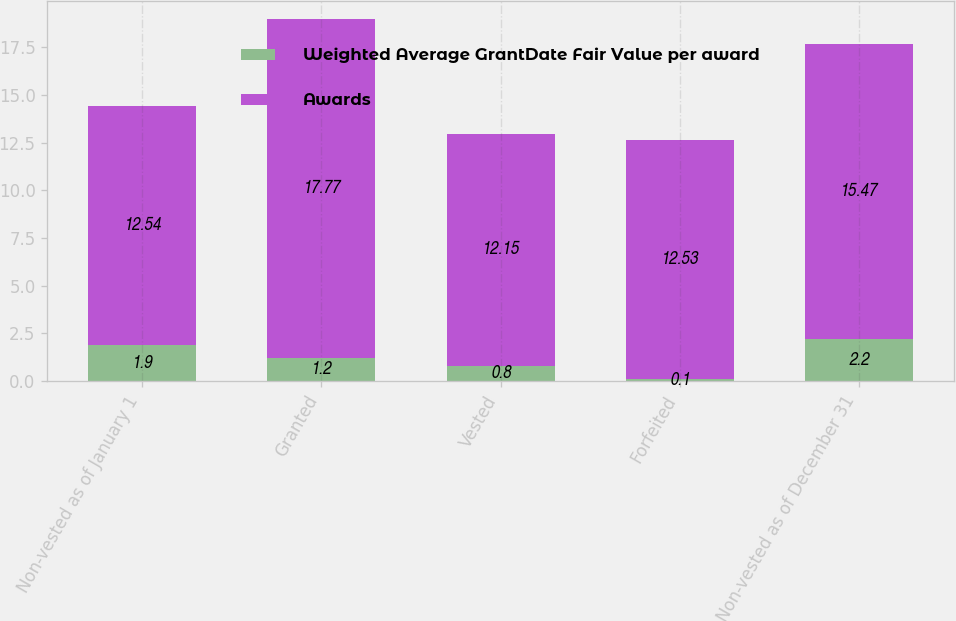<chart> <loc_0><loc_0><loc_500><loc_500><stacked_bar_chart><ecel><fcel>Non-vested as of January 1<fcel>Granted<fcel>Vested<fcel>Forfeited<fcel>Non-vested as of December 31<nl><fcel>Weighted Average GrantDate Fair Value per award<fcel>1.9<fcel>1.2<fcel>0.8<fcel>0.1<fcel>2.2<nl><fcel>Awards<fcel>12.54<fcel>17.77<fcel>12.15<fcel>12.53<fcel>15.47<nl></chart> 